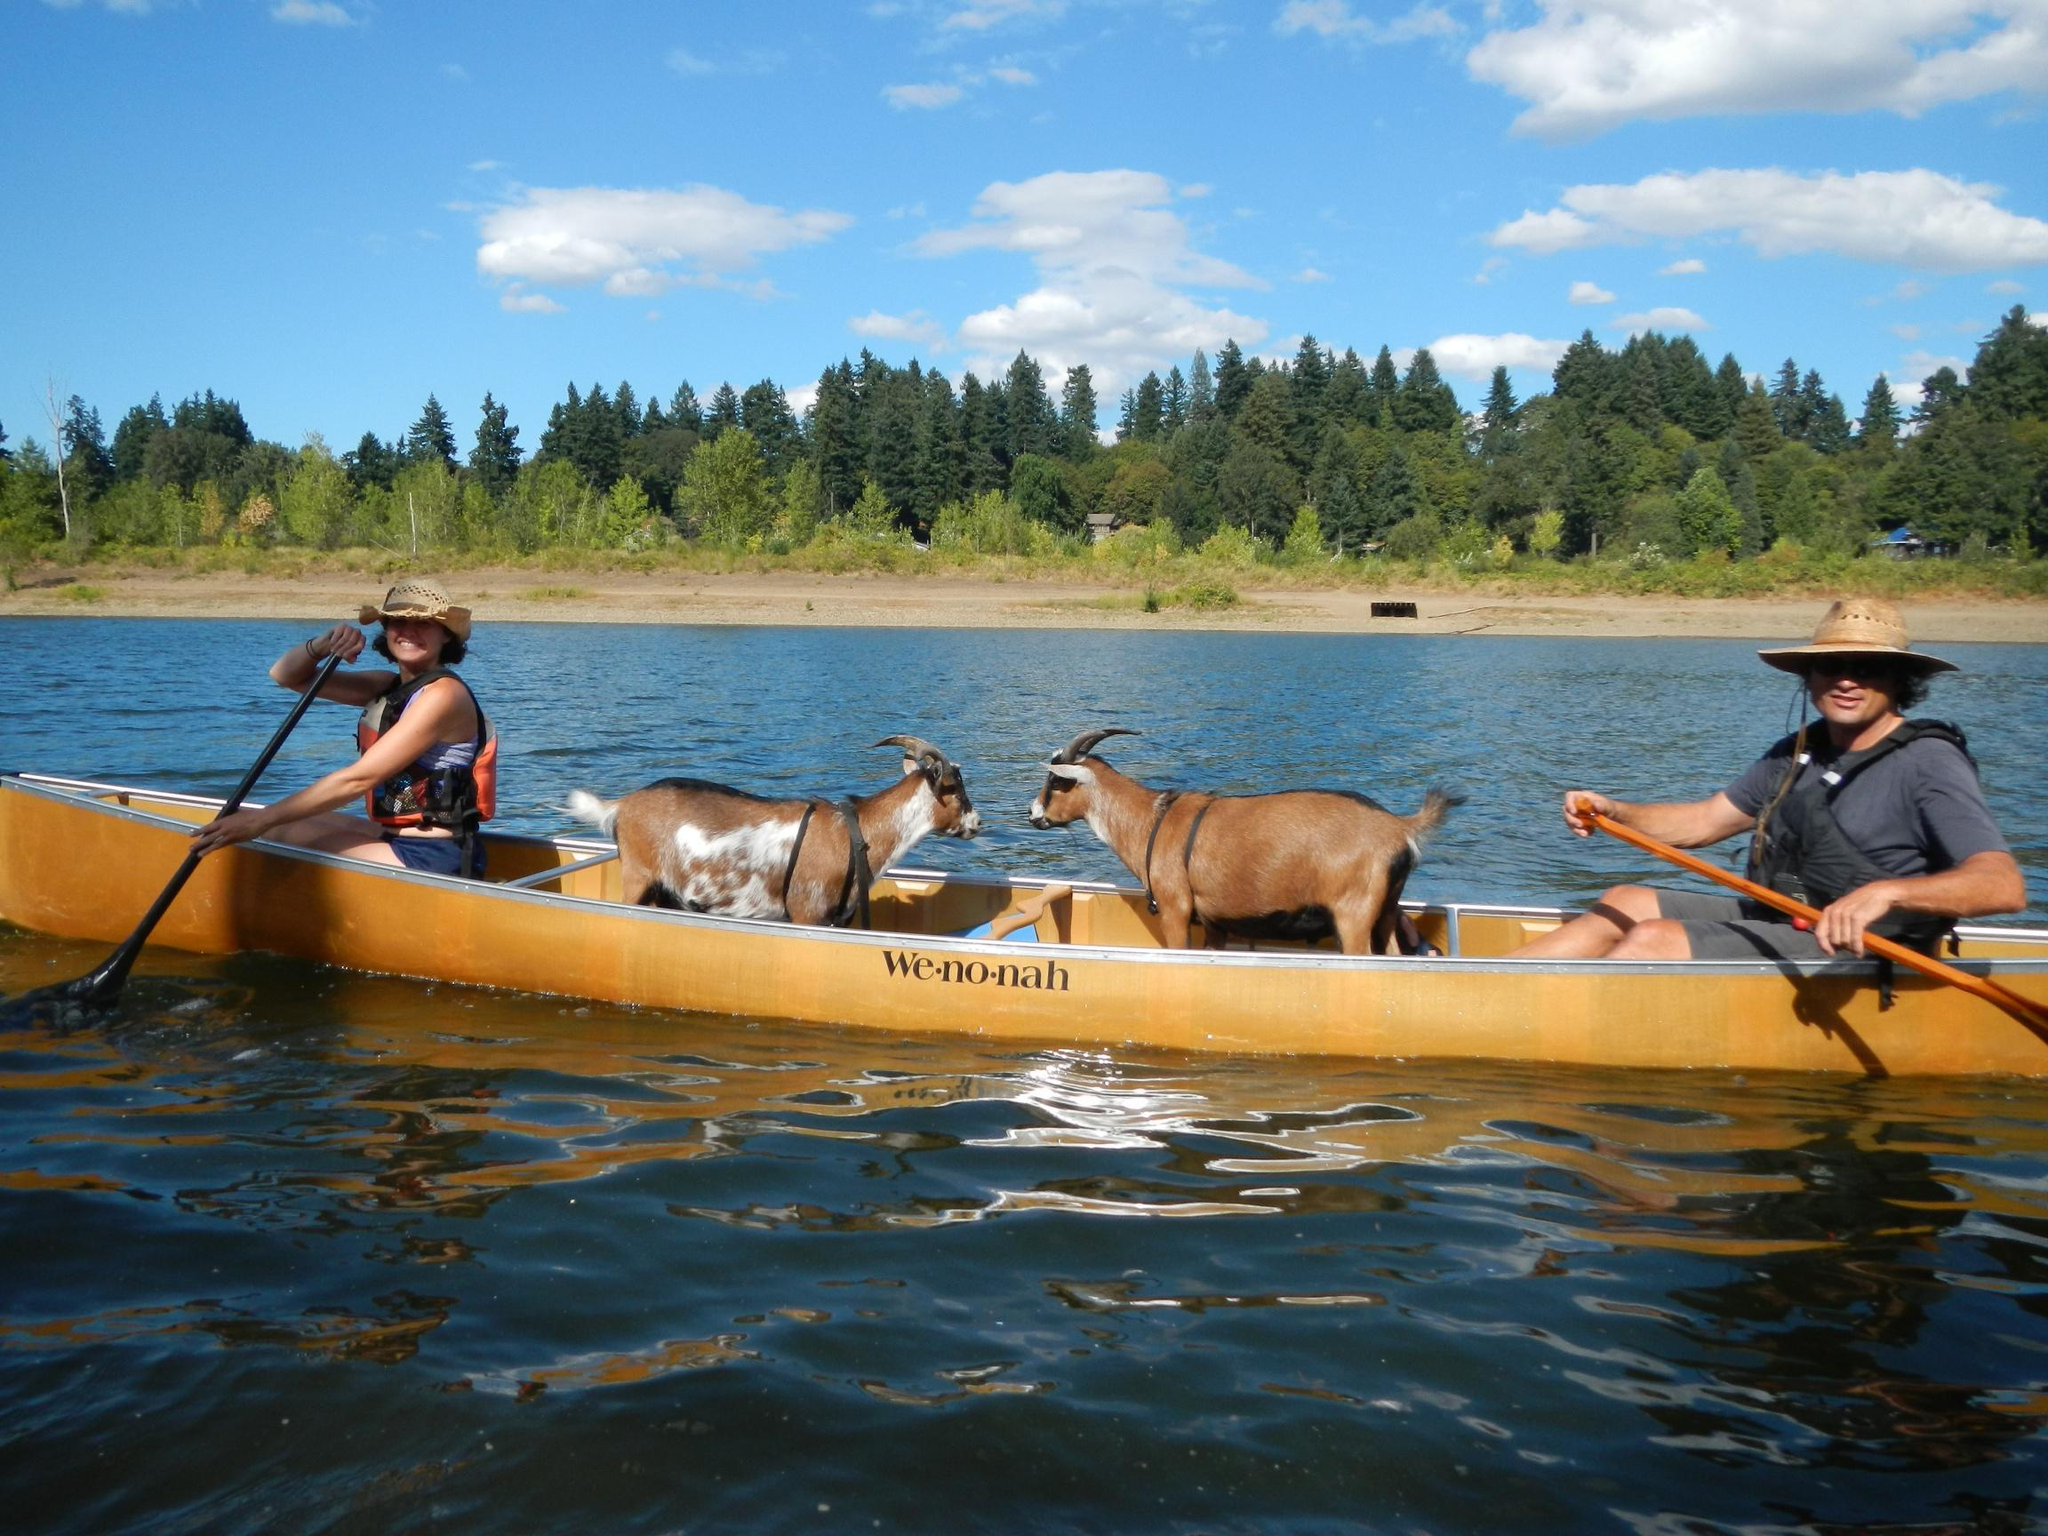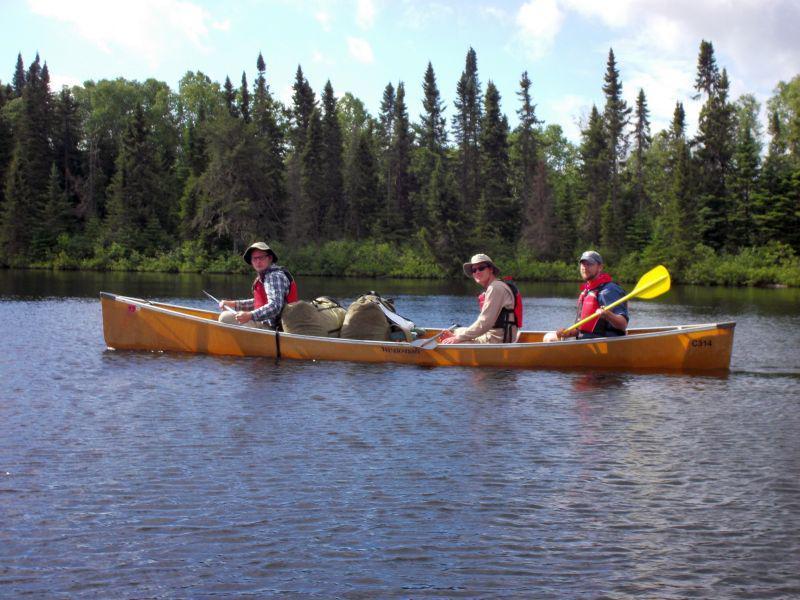The first image is the image on the left, the second image is the image on the right. Given the left and right images, does the statement "In each picture on the right, there are 3 people in a red canoe." hold true? Answer yes or no. No. 